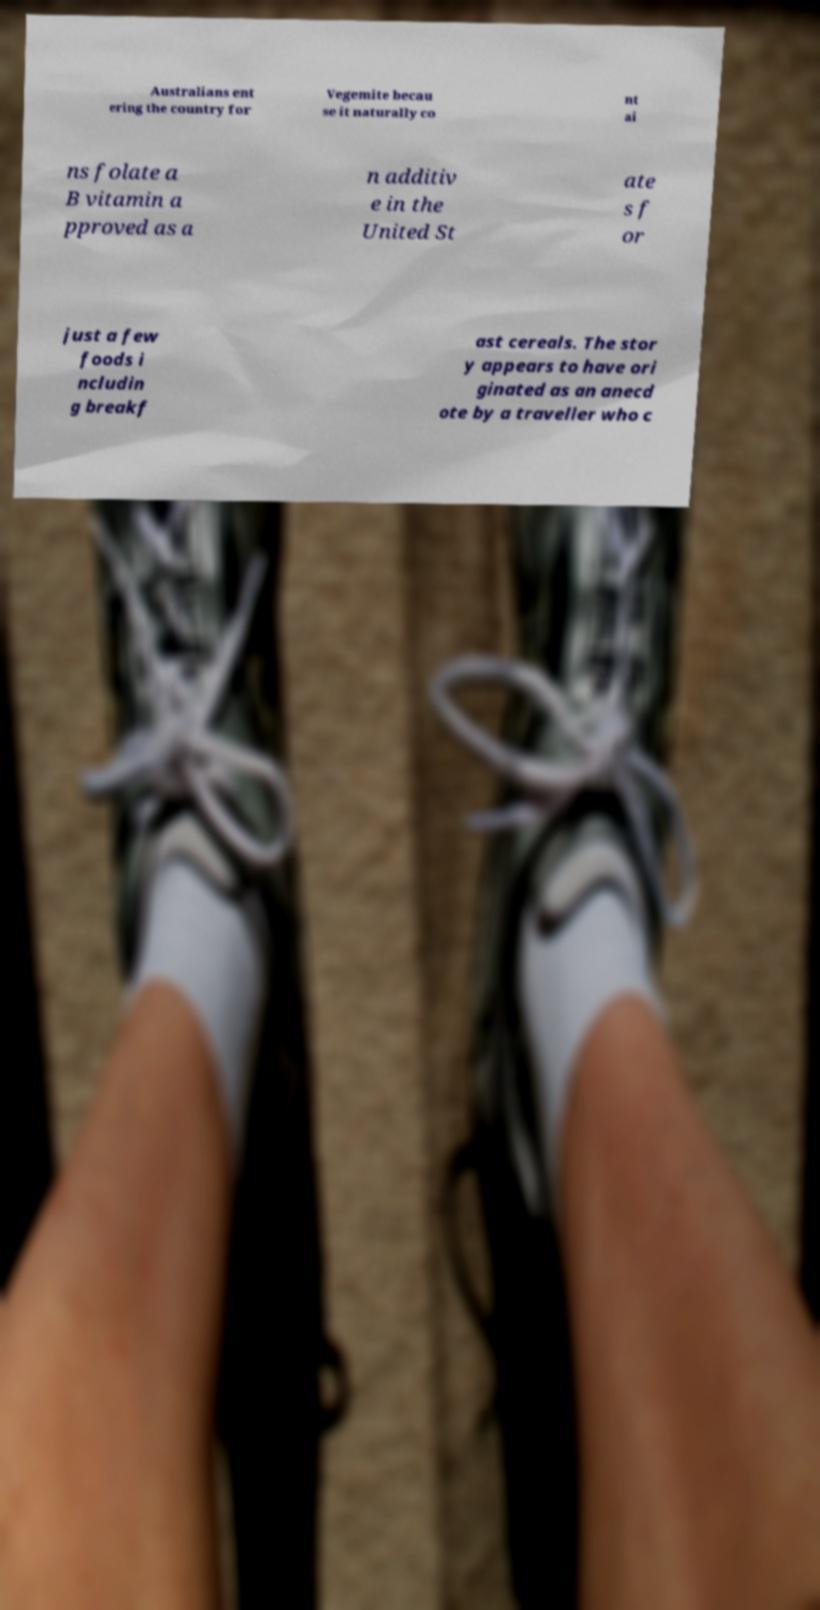There's text embedded in this image that I need extracted. Can you transcribe it verbatim? Australians ent ering the country for Vegemite becau se it naturally co nt ai ns folate a B vitamin a pproved as a n additiv e in the United St ate s f or just a few foods i ncludin g breakf ast cereals. The stor y appears to have ori ginated as an anecd ote by a traveller who c 